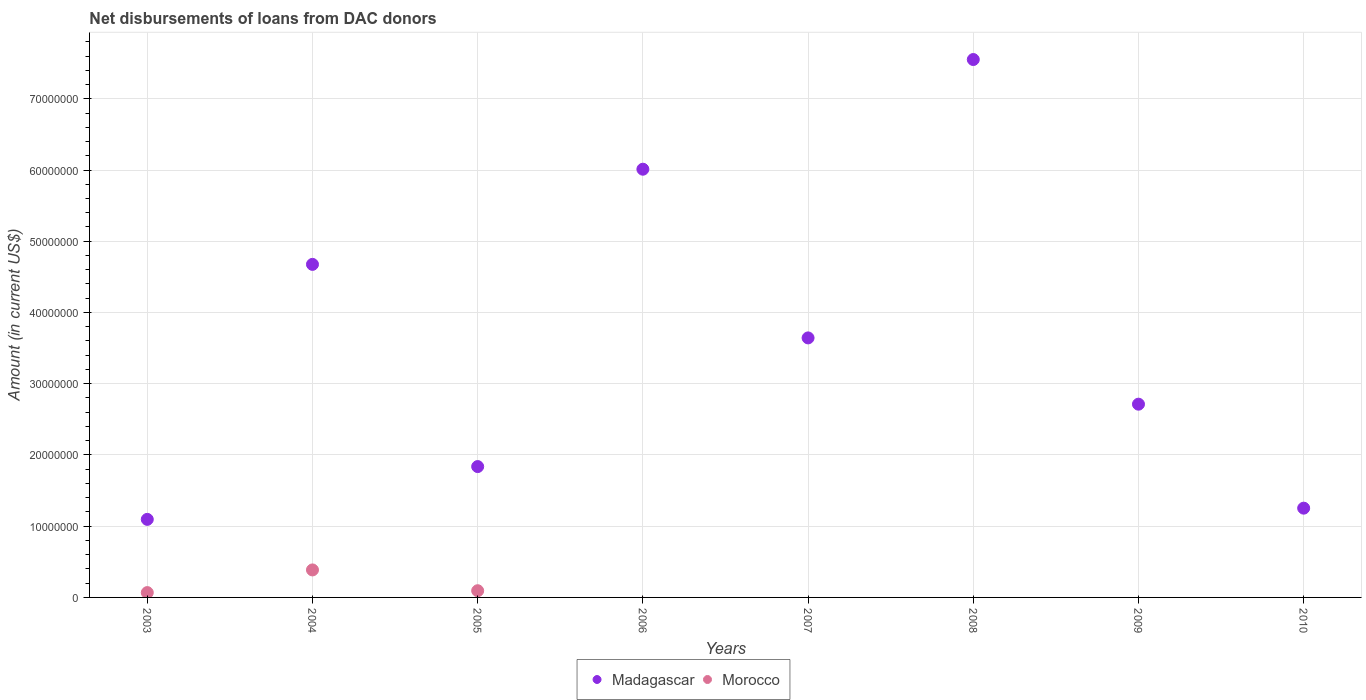How many different coloured dotlines are there?
Ensure brevity in your answer.  2. Is the number of dotlines equal to the number of legend labels?
Provide a succinct answer. No. What is the amount of loans disbursed in Madagascar in 2003?
Your answer should be compact. 1.10e+07. Across all years, what is the maximum amount of loans disbursed in Madagascar?
Offer a very short reply. 7.55e+07. Across all years, what is the minimum amount of loans disbursed in Madagascar?
Make the answer very short. 1.10e+07. What is the total amount of loans disbursed in Madagascar in the graph?
Keep it short and to the point. 2.88e+08. What is the difference between the amount of loans disbursed in Madagascar in 2004 and that in 2005?
Provide a short and direct response. 2.84e+07. What is the difference between the amount of loans disbursed in Morocco in 2006 and the amount of loans disbursed in Madagascar in 2007?
Provide a short and direct response. -3.64e+07. What is the average amount of loans disbursed in Morocco per year?
Provide a short and direct response. 6.85e+05. In the year 2004, what is the difference between the amount of loans disbursed in Madagascar and amount of loans disbursed in Morocco?
Provide a succinct answer. 4.29e+07. In how many years, is the amount of loans disbursed in Morocco greater than 74000000 US$?
Ensure brevity in your answer.  0. What is the ratio of the amount of loans disbursed in Madagascar in 2005 to that in 2006?
Ensure brevity in your answer.  0.31. Is the difference between the amount of loans disbursed in Madagascar in 2003 and 2005 greater than the difference between the amount of loans disbursed in Morocco in 2003 and 2005?
Make the answer very short. No. What is the difference between the highest and the second highest amount of loans disbursed in Morocco?
Offer a terse response. 2.92e+06. What is the difference between the highest and the lowest amount of loans disbursed in Morocco?
Provide a succinct answer. 3.86e+06. In how many years, is the amount of loans disbursed in Madagascar greater than the average amount of loans disbursed in Madagascar taken over all years?
Provide a short and direct response. 4. Is the sum of the amount of loans disbursed in Morocco in 2004 and 2005 greater than the maximum amount of loans disbursed in Madagascar across all years?
Make the answer very short. No. Is the amount of loans disbursed in Morocco strictly greater than the amount of loans disbursed in Madagascar over the years?
Your answer should be very brief. No. What is the difference between two consecutive major ticks on the Y-axis?
Offer a very short reply. 1.00e+07. Are the values on the major ticks of Y-axis written in scientific E-notation?
Keep it short and to the point. No. How many legend labels are there?
Your answer should be compact. 2. What is the title of the graph?
Give a very brief answer. Net disbursements of loans from DAC donors. What is the Amount (in current US$) of Madagascar in 2003?
Your answer should be compact. 1.10e+07. What is the Amount (in current US$) of Morocco in 2003?
Keep it short and to the point. 6.78e+05. What is the Amount (in current US$) in Madagascar in 2004?
Give a very brief answer. 4.68e+07. What is the Amount (in current US$) in Morocco in 2004?
Keep it short and to the point. 3.86e+06. What is the Amount (in current US$) in Madagascar in 2005?
Provide a short and direct response. 1.84e+07. What is the Amount (in current US$) of Morocco in 2005?
Provide a short and direct response. 9.41e+05. What is the Amount (in current US$) of Madagascar in 2006?
Provide a succinct answer. 6.01e+07. What is the Amount (in current US$) in Madagascar in 2007?
Provide a short and direct response. 3.64e+07. What is the Amount (in current US$) of Madagascar in 2008?
Offer a terse response. 7.55e+07. What is the Amount (in current US$) in Madagascar in 2009?
Your answer should be compact. 2.71e+07. What is the Amount (in current US$) in Madagascar in 2010?
Make the answer very short. 1.25e+07. Across all years, what is the maximum Amount (in current US$) of Madagascar?
Offer a terse response. 7.55e+07. Across all years, what is the maximum Amount (in current US$) in Morocco?
Provide a short and direct response. 3.86e+06. Across all years, what is the minimum Amount (in current US$) of Madagascar?
Offer a terse response. 1.10e+07. Across all years, what is the minimum Amount (in current US$) of Morocco?
Ensure brevity in your answer.  0. What is the total Amount (in current US$) of Madagascar in the graph?
Keep it short and to the point. 2.88e+08. What is the total Amount (in current US$) in Morocco in the graph?
Your answer should be very brief. 5.48e+06. What is the difference between the Amount (in current US$) in Madagascar in 2003 and that in 2004?
Your answer should be very brief. -3.58e+07. What is the difference between the Amount (in current US$) in Morocco in 2003 and that in 2004?
Provide a short and direct response. -3.18e+06. What is the difference between the Amount (in current US$) of Madagascar in 2003 and that in 2005?
Your answer should be very brief. -7.41e+06. What is the difference between the Amount (in current US$) of Morocco in 2003 and that in 2005?
Ensure brevity in your answer.  -2.63e+05. What is the difference between the Amount (in current US$) in Madagascar in 2003 and that in 2006?
Make the answer very short. -4.92e+07. What is the difference between the Amount (in current US$) of Madagascar in 2003 and that in 2007?
Offer a very short reply. -2.55e+07. What is the difference between the Amount (in current US$) in Madagascar in 2003 and that in 2008?
Keep it short and to the point. -6.46e+07. What is the difference between the Amount (in current US$) in Madagascar in 2003 and that in 2009?
Make the answer very short. -1.62e+07. What is the difference between the Amount (in current US$) in Madagascar in 2003 and that in 2010?
Offer a very short reply. -1.57e+06. What is the difference between the Amount (in current US$) in Madagascar in 2004 and that in 2005?
Provide a short and direct response. 2.84e+07. What is the difference between the Amount (in current US$) of Morocco in 2004 and that in 2005?
Provide a short and direct response. 2.92e+06. What is the difference between the Amount (in current US$) in Madagascar in 2004 and that in 2006?
Your answer should be compact. -1.34e+07. What is the difference between the Amount (in current US$) in Madagascar in 2004 and that in 2007?
Provide a succinct answer. 1.03e+07. What is the difference between the Amount (in current US$) of Madagascar in 2004 and that in 2008?
Offer a terse response. -2.88e+07. What is the difference between the Amount (in current US$) of Madagascar in 2004 and that in 2009?
Ensure brevity in your answer.  1.96e+07. What is the difference between the Amount (in current US$) of Madagascar in 2004 and that in 2010?
Offer a very short reply. 3.42e+07. What is the difference between the Amount (in current US$) of Madagascar in 2005 and that in 2006?
Your answer should be compact. -4.17e+07. What is the difference between the Amount (in current US$) in Madagascar in 2005 and that in 2007?
Ensure brevity in your answer.  -1.81e+07. What is the difference between the Amount (in current US$) of Madagascar in 2005 and that in 2008?
Your response must be concise. -5.71e+07. What is the difference between the Amount (in current US$) in Madagascar in 2005 and that in 2009?
Provide a short and direct response. -8.76e+06. What is the difference between the Amount (in current US$) in Madagascar in 2005 and that in 2010?
Offer a very short reply. 5.84e+06. What is the difference between the Amount (in current US$) of Madagascar in 2006 and that in 2007?
Offer a terse response. 2.37e+07. What is the difference between the Amount (in current US$) in Madagascar in 2006 and that in 2008?
Your answer should be compact. -1.54e+07. What is the difference between the Amount (in current US$) in Madagascar in 2006 and that in 2009?
Provide a succinct answer. 3.30e+07. What is the difference between the Amount (in current US$) of Madagascar in 2006 and that in 2010?
Give a very brief answer. 4.76e+07. What is the difference between the Amount (in current US$) in Madagascar in 2007 and that in 2008?
Offer a very short reply. -3.91e+07. What is the difference between the Amount (in current US$) of Madagascar in 2007 and that in 2009?
Keep it short and to the point. 9.30e+06. What is the difference between the Amount (in current US$) of Madagascar in 2007 and that in 2010?
Offer a very short reply. 2.39e+07. What is the difference between the Amount (in current US$) in Madagascar in 2008 and that in 2009?
Offer a very short reply. 4.84e+07. What is the difference between the Amount (in current US$) of Madagascar in 2008 and that in 2010?
Ensure brevity in your answer.  6.30e+07. What is the difference between the Amount (in current US$) of Madagascar in 2009 and that in 2010?
Give a very brief answer. 1.46e+07. What is the difference between the Amount (in current US$) in Madagascar in 2003 and the Amount (in current US$) in Morocco in 2004?
Provide a succinct answer. 7.10e+06. What is the difference between the Amount (in current US$) in Madagascar in 2003 and the Amount (in current US$) in Morocco in 2005?
Make the answer very short. 1.00e+07. What is the difference between the Amount (in current US$) in Madagascar in 2004 and the Amount (in current US$) in Morocco in 2005?
Your answer should be very brief. 4.58e+07. What is the average Amount (in current US$) of Madagascar per year?
Offer a terse response. 3.60e+07. What is the average Amount (in current US$) in Morocco per year?
Keep it short and to the point. 6.85e+05. In the year 2003, what is the difference between the Amount (in current US$) of Madagascar and Amount (in current US$) of Morocco?
Offer a very short reply. 1.03e+07. In the year 2004, what is the difference between the Amount (in current US$) of Madagascar and Amount (in current US$) of Morocco?
Offer a terse response. 4.29e+07. In the year 2005, what is the difference between the Amount (in current US$) of Madagascar and Amount (in current US$) of Morocco?
Provide a short and direct response. 1.74e+07. What is the ratio of the Amount (in current US$) of Madagascar in 2003 to that in 2004?
Your answer should be very brief. 0.23. What is the ratio of the Amount (in current US$) in Morocco in 2003 to that in 2004?
Offer a very short reply. 0.18. What is the ratio of the Amount (in current US$) of Madagascar in 2003 to that in 2005?
Your answer should be compact. 0.6. What is the ratio of the Amount (in current US$) in Morocco in 2003 to that in 2005?
Offer a very short reply. 0.72. What is the ratio of the Amount (in current US$) in Madagascar in 2003 to that in 2006?
Ensure brevity in your answer.  0.18. What is the ratio of the Amount (in current US$) of Madagascar in 2003 to that in 2007?
Your response must be concise. 0.3. What is the ratio of the Amount (in current US$) of Madagascar in 2003 to that in 2008?
Your answer should be compact. 0.15. What is the ratio of the Amount (in current US$) of Madagascar in 2003 to that in 2009?
Ensure brevity in your answer.  0.4. What is the ratio of the Amount (in current US$) in Madagascar in 2003 to that in 2010?
Your response must be concise. 0.87. What is the ratio of the Amount (in current US$) of Madagascar in 2004 to that in 2005?
Ensure brevity in your answer.  2.55. What is the ratio of the Amount (in current US$) of Morocco in 2004 to that in 2005?
Your answer should be compact. 4.1. What is the ratio of the Amount (in current US$) in Madagascar in 2004 to that in 2006?
Make the answer very short. 0.78. What is the ratio of the Amount (in current US$) in Madagascar in 2004 to that in 2007?
Ensure brevity in your answer.  1.28. What is the ratio of the Amount (in current US$) of Madagascar in 2004 to that in 2008?
Ensure brevity in your answer.  0.62. What is the ratio of the Amount (in current US$) of Madagascar in 2004 to that in 2009?
Your answer should be very brief. 1.72. What is the ratio of the Amount (in current US$) of Madagascar in 2004 to that in 2010?
Give a very brief answer. 3.73. What is the ratio of the Amount (in current US$) in Madagascar in 2005 to that in 2006?
Give a very brief answer. 0.31. What is the ratio of the Amount (in current US$) in Madagascar in 2005 to that in 2007?
Offer a terse response. 0.5. What is the ratio of the Amount (in current US$) in Madagascar in 2005 to that in 2008?
Make the answer very short. 0.24. What is the ratio of the Amount (in current US$) in Madagascar in 2005 to that in 2009?
Offer a very short reply. 0.68. What is the ratio of the Amount (in current US$) of Madagascar in 2005 to that in 2010?
Ensure brevity in your answer.  1.47. What is the ratio of the Amount (in current US$) in Madagascar in 2006 to that in 2007?
Make the answer very short. 1.65. What is the ratio of the Amount (in current US$) of Madagascar in 2006 to that in 2008?
Offer a terse response. 0.8. What is the ratio of the Amount (in current US$) of Madagascar in 2006 to that in 2009?
Offer a terse response. 2.22. What is the ratio of the Amount (in current US$) in Madagascar in 2006 to that in 2010?
Offer a terse response. 4.8. What is the ratio of the Amount (in current US$) of Madagascar in 2007 to that in 2008?
Give a very brief answer. 0.48. What is the ratio of the Amount (in current US$) in Madagascar in 2007 to that in 2009?
Ensure brevity in your answer.  1.34. What is the ratio of the Amount (in current US$) in Madagascar in 2007 to that in 2010?
Provide a short and direct response. 2.91. What is the ratio of the Amount (in current US$) in Madagascar in 2008 to that in 2009?
Provide a succinct answer. 2.78. What is the ratio of the Amount (in current US$) in Madagascar in 2008 to that in 2010?
Ensure brevity in your answer.  6.03. What is the ratio of the Amount (in current US$) in Madagascar in 2009 to that in 2010?
Provide a short and direct response. 2.16. What is the difference between the highest and the second highest Amount (in current US$) in Madagascar?
Give a very brief answer. 1.54e+07. What is the difference between the highest and the second highest Amount (in current US$) of Morocco?
Your answer should be very brief. 2.92e+06. What is the difference between the highest and the lowest Amount (in current US$) of Madagascar?
Ensure brevity in your answer.  6.46e+07. What is the difference between the highest and the lowest Amount (in current US$) in Morocco?
Offer a terse response. 3.86e+06. 